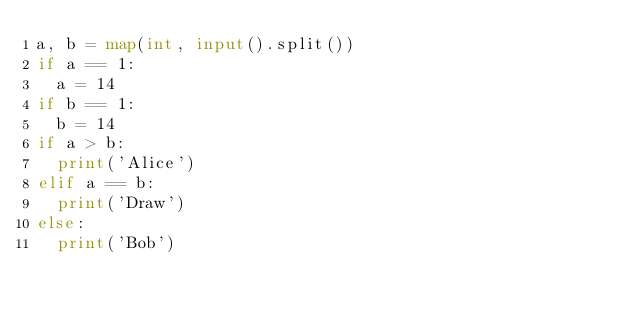Convert code to text. <code><loc_0><loc_0><loc_500><loc_500><_Python_>a, b = map(int, input().split())
if a == 1:
  a = 14
if b == 1:
  b = 14
if a > b:
  print('Alice')
elif a == b:
  print('Draw')
else:
  print('Bob')</code> 